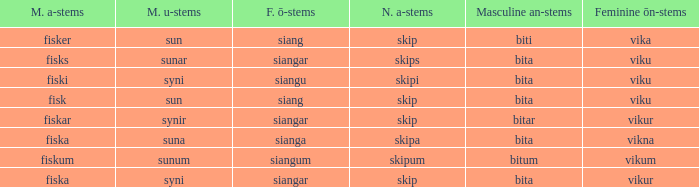Write the full table. {'header': ['M. a-stems', 'M. u-stems', 'F. ō-stems', 'N. a-stems', 'Masculine an-stems', 'Feminine ōn-stems'], 'rows': [['fisker', 'sun', 'siang', 'skip', 'biti', 'vika'], ['fisks', 'sunar', 'siangar', 'skips', 'bita', 'viku'], ['fiski', 'syni', 'siangu', 'skipi', 'bita', 'viku'], ['fisk', 'sun', 'siang', 'skip', 'bita', 'viku'], ['fiskar', 'synir', 'siangar', 'skip', 'bitar', 'vikur'], ['fiska', 'suna', 'sianga', 'skipa', 'bita', 'vikna'], ['fiskum', 'sunum', 'siangum', 'skipum', 'bitum', 'vikum'], ['fiska', 'syni', 'siangar', 'skip', 'bita', 'vikur']]} What is the masculine an form for the word with a feminine ö ending of siangar and a masculine u ending of sunar? Bita. 